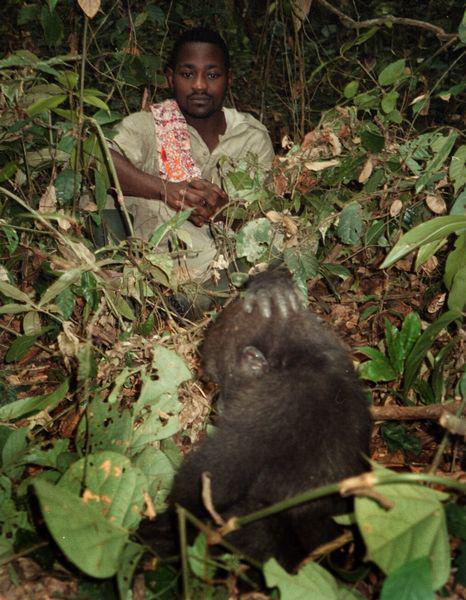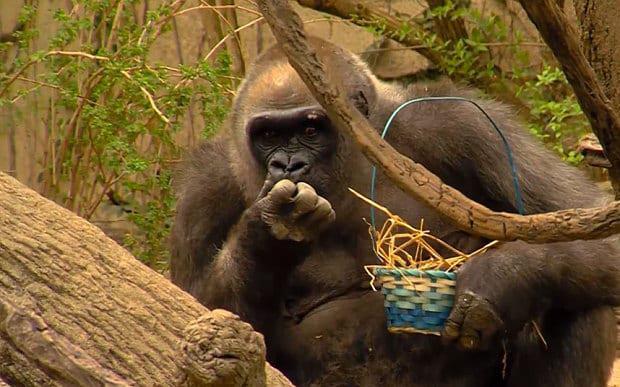The first image is the image on the left, the second image is the image on the right. Evaluate the accuracy of this statement regarding the images: "An image shows one man in a scene with a dark-haired ape.". Is it true? Answer yes or no. Yes. The first image is the image on the left, the second image is the image on the right. For the images shown, is this caption "Each gorilla is standing on at least two legs." true? Answer yes or no. No. 